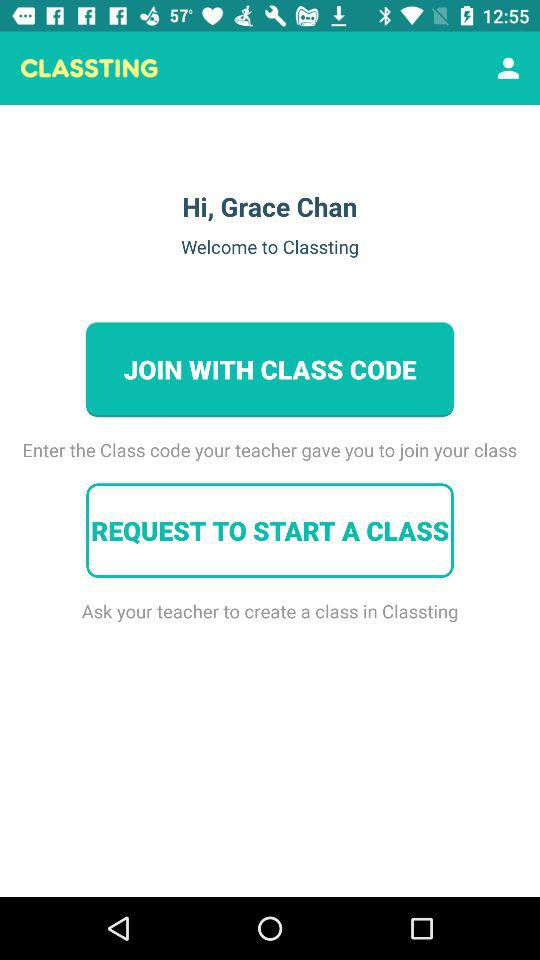What is the login name? The login name is "Grace Chan". 